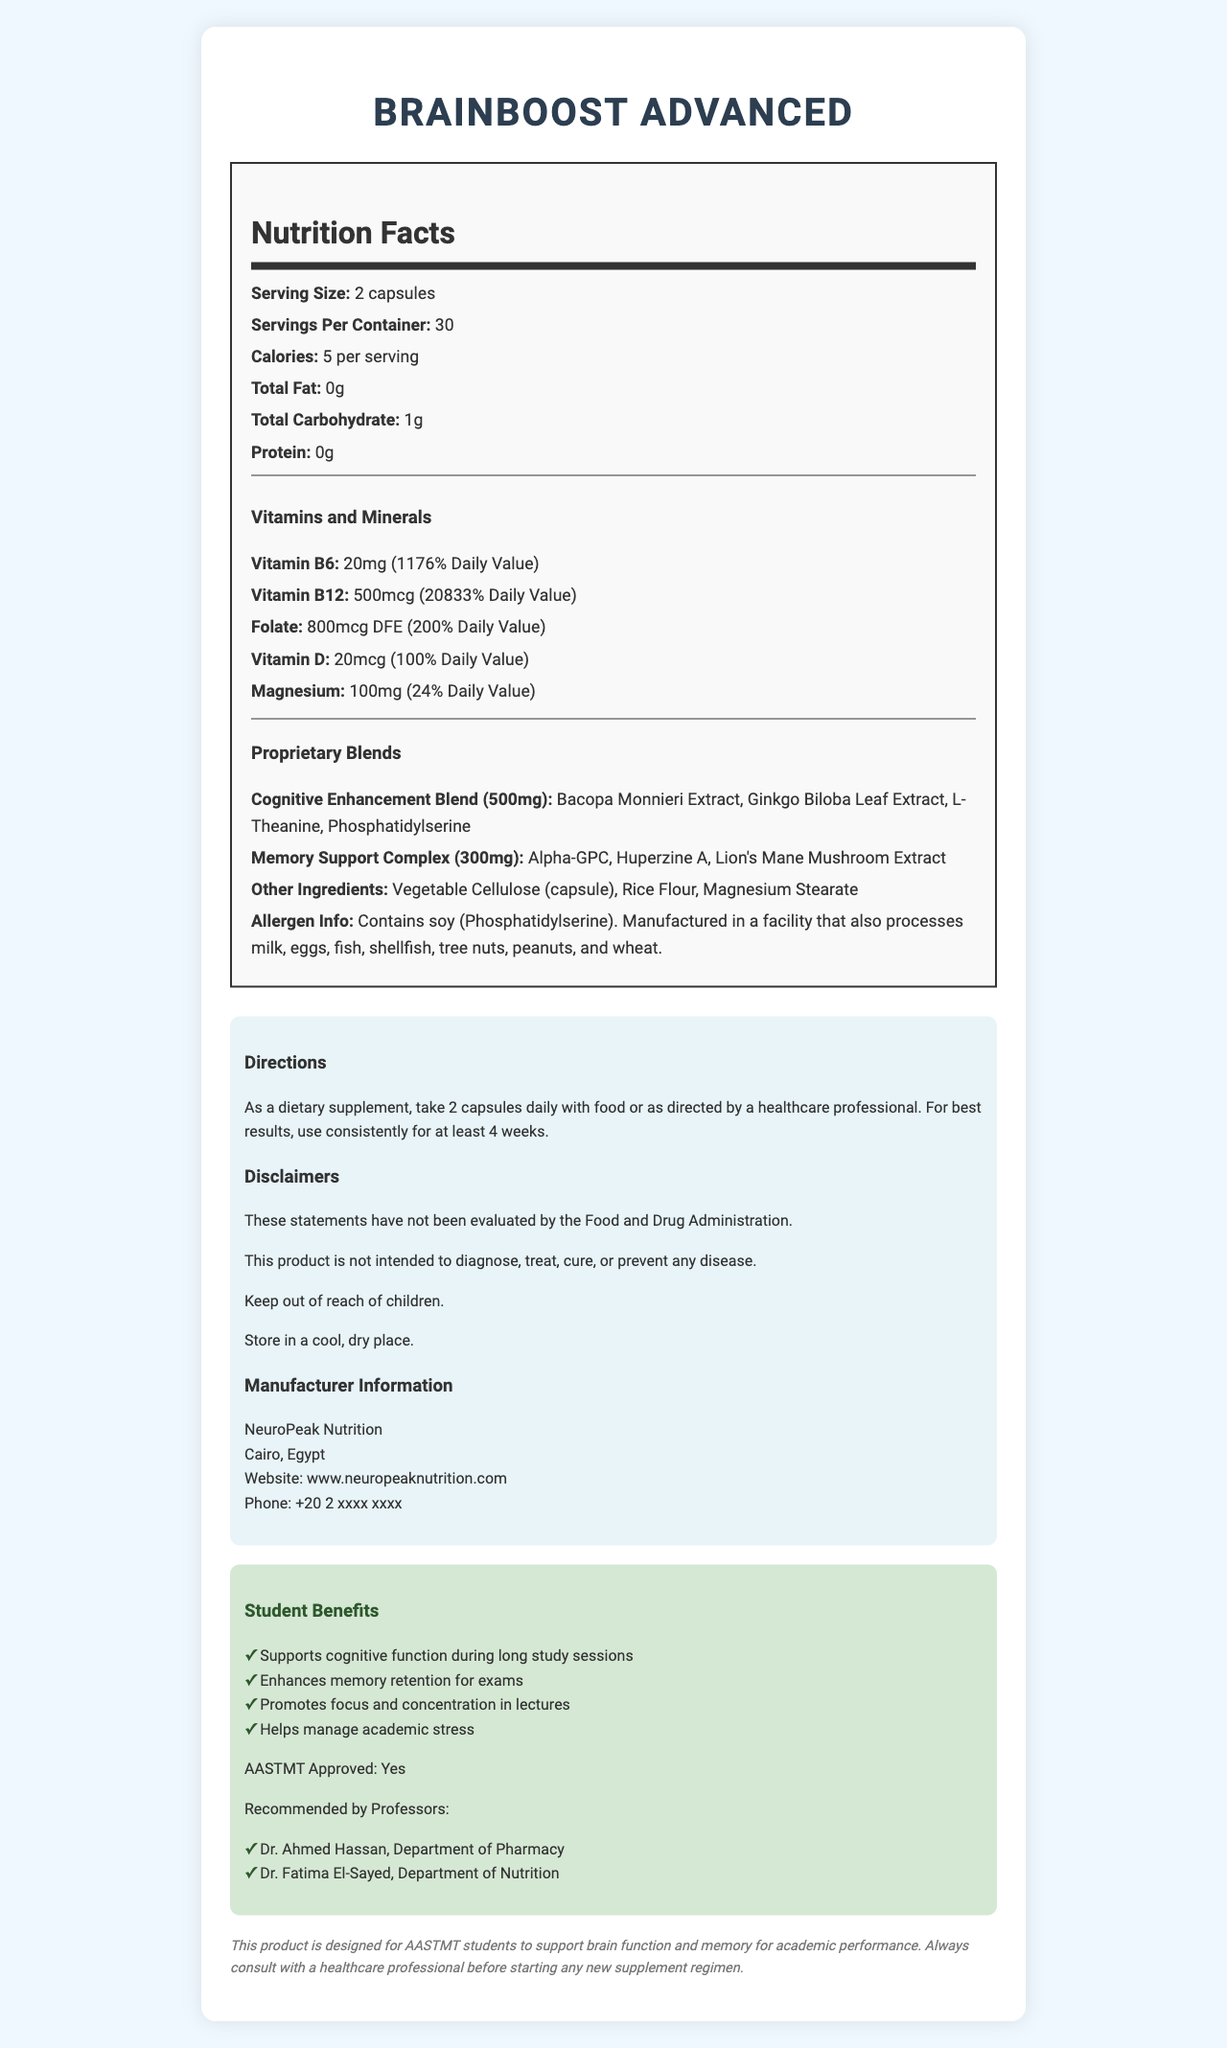what is the serving size? The document states that the serving size is 2 capsules.
Answer: 2 capsules how many servings are there in one container? The document indicates that there are 30 servings per container.
Answer: 30 how many calories are in one serving? The document specifies that each serving contains 5 calories.
Answer: 5 calories how much Vitamin B6 is in one serving? The document lists the amount of Vitamin B6 as 20mg per serving.
Answer: 20mg how much Folate does this supplement provide in one serving? According to the document, one serving provides 800mcg DFE of Folate.
Answer: 800mcg DFE what are the main ingredients of the Cognitive Enhancement Blend? The Cognitive Enhancement Blend includes these ingredients as listed in the document.
Answer: Bacopa Monnieri Extract, Ginkgo Biloba Leaf Extract, L-Theanine, Phosphatidylserine which professor from the Department of Nutrition recommends this product? The document mentions Dr. Fatima El-Sayed from the Department of Nutrition as one of the recommending professors.
Answer: Dr. Fatima El-Sayed what is the total amount of the Memory Support Complex per serving? The Memory Support Complex totals 300mg per serving according to the document.
Answer: 300mg what should you do for best results when taking this supplement? The directions in the document recommend using the supplement consistently for at least 4 weeks for best results.
Answer: Use consistently for at least 4 weeks what allergens are present in this product? The document's allergen information states that the product contains soy (Phosphatidylserine).
Answer: Soy (Phosphatidylserine) which of the following is NOT an ingredient in the Cognitive Enhancement Blend? A. Bacopa Monnieri Extract B. Ginkgo Biloba Leaf Extract C. Alpha-GPC D. L-Theanine The document indicates that Alpha-GPC is part of the Memory Support Complex, not the Cognitive Enhancement Blend.
Answer: C. Alpha-GPC which vitamin has the highest daily value percentage in this supplement? A. Vitamin B6 B. Vitamin B12 C. Folate D. Vitamin D The document shows Vitamin B12 with a daily value of 20833%, which is the highest among the listed vitamins.
Answer: B. Vitamin B12 is this product AASTMT approved? The document explicitly states that the product is AASTMT approved.
Answer: Yes summarize the main details of this document. This summary captures the main points and structure of the document, including the purpose, key ingredients, benefits, recommendations, and other important information.
Answer: The document details the nutrition facts of the BrainBoost Advanced supplement. It includes information on serving size, calories, vitamins and minerals, proprietary blends, and other ingredients. It outlines the product's benefits for students, especially for cognitive function and memory support, and provides usage directions, allergen information, disclaimers, and manufacturer details. The product is approved by AASTMT and recommended by professors. how many micrograms of Vitamin D are there per serving? The document specifies that there are 20mcg of Vitamin D per serving.
Answer: 20mcg can this supplement be used to diagnose, treat, cure, or prevent diseases? The document includes a disclaimer stating that the product is not intended to diagnose, treat, cure, or prevent any disease.
Answer: No is Bacopa Monnieri Extract part of the Memory Support Complex? Bacopa Monnieri Extract is listed as part of the Cognitive Enhancement Blend, not the Memory Support Complex according to the document.
Answer: No how many calories from fat are there in one serving? The document states the calories per serving (5 calories) and the total fat (0g), but does not mention the specific calories from fat.
Answer: Not enough information 